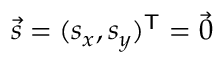Convert formula to latex. <formula><loc_0><loc_0><loc_500><loc_500>{ \vec { s } } = ( s _ { x } , s _ { y } ) ^ { T } = { \vec { 0 } } \,</formula> 